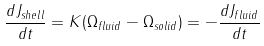Convert formula to latex. <formula><loc_0><loc_0><loc_500><loc_500>\frac { d J _ { s h e l l } } { d t } = K ( { \Omega _ { f l u i d } - \Omega _ { s o l i d } } ) = - \frac { d J _ { f l u i d } } { d t }</formula> 